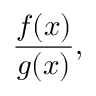<formula> <loc_0><loc_0><loc_500><loc_500>{ \frac { f ( x ) } { g ( x ) } } ,</formula> 